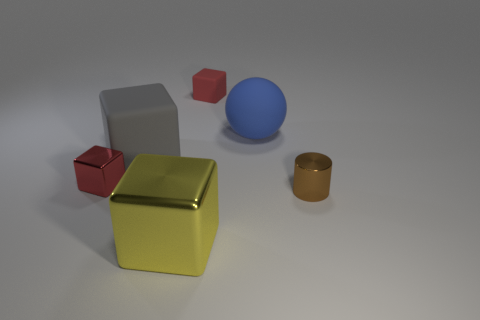Subtract all tiny metallic blocks. How many blocks are left? 3 Subtract all green spheres. How many red cubes are left? 2 Add 2 small purple objects. How many objects exist? 8 Subtract all gray cubes. How many cubes are left? 3 Subtract all cubes. How many objects are left? 2 Add 5 metallic objects. How many metallic objects are left? 8 Add 4 brown objects. How many brown objects exist? 5 Subtract 0 gray balls. How many objects are left? 6 Subtract 1 cubes. How many cubes are left? 3 Subtract all cyan cubes. Subtract all blue spheres. How many cubes are left? 4 